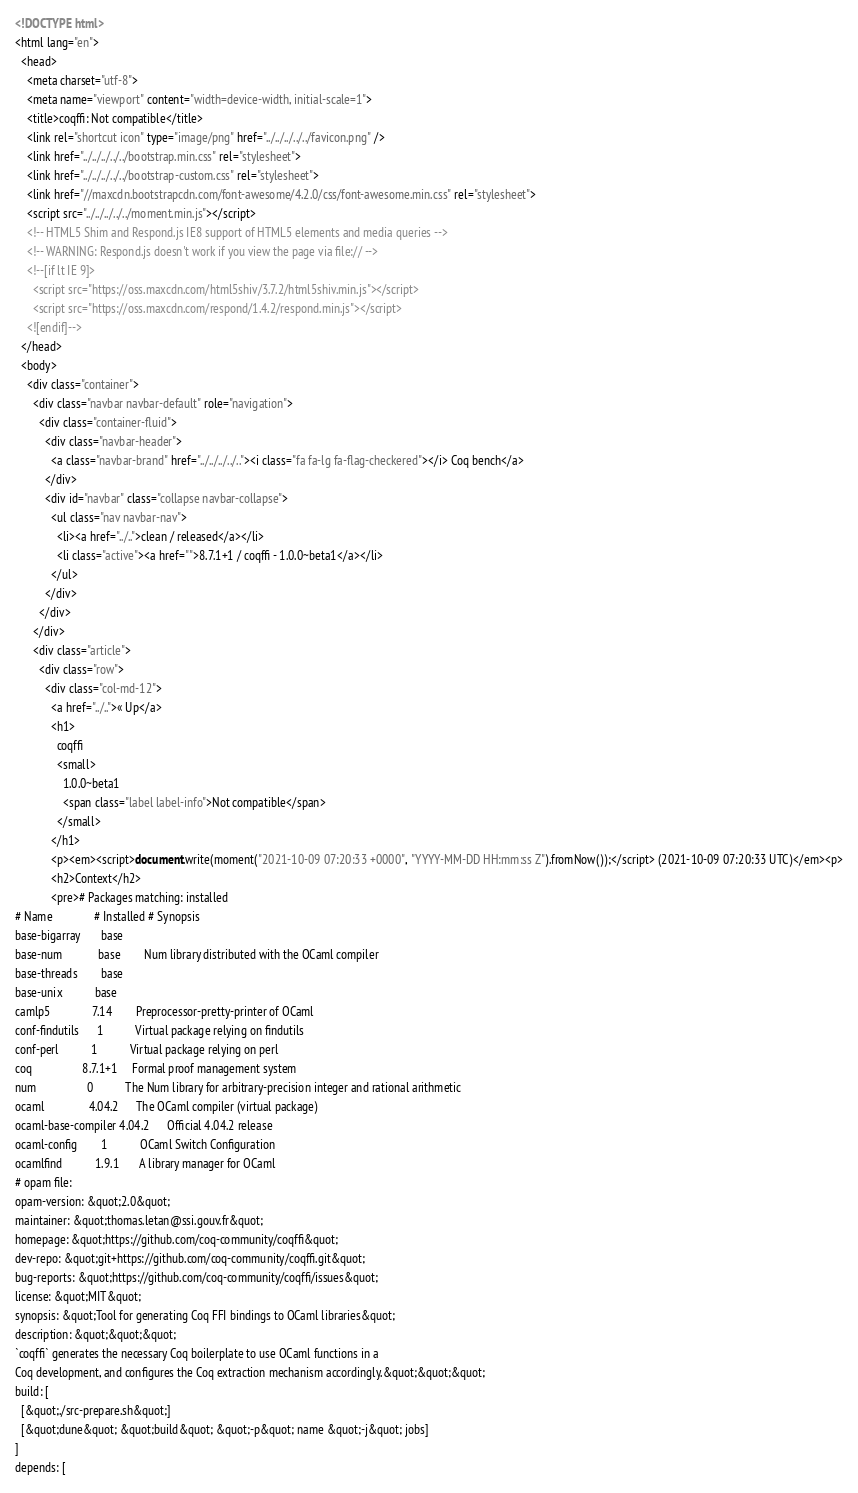<code> <loc_0><loc_0><loc_500><loc_500><_HTML_><!DOCTYPE html>
<html lang="en">
  <head>
    <meta charset="utf-8">
    <meta name="viewport" content="width=device-width, initial-scale=1">
    <title>coqffi: Not compatible</title>
    <link rel="shortcut icon" type="image/png" href="../../../../../favicon.png" />
    <link href="../../../../../bootstrap.min.css" rel="stylesheet">
    <link href="../../../../../bootstrap-custom.css" rel="stylesheet">
    <link href="//maxcdn.bootstrapcdn.com/font-awesome/4.2.0/css/font-awesome.min.css" rel="stylesheet">
    <script src="../../../../../moment.min.js"></script>
    <!-- HTML5 Shim and Respond.js IE8 support of HTML5 elements and media queries -->
    <!-- WARNING: Respond.js doesn't work if you view the page via file:// -->
    <!--[if lt IE 9]>
      <script src="https://oss.maxcdn.com/html5shiv/3.7.2/html5shiv.min.js"></script>
      <script src="https://oss.maxcdn.com/respond/1.4.2/respond.min.js"></script>
    <![endif]-->
  </head>
  <body>
    <div class="container">
      <div class="navbar navbar-default" role="navigation">
        <div class="container-fluid">
          <div class="navbar-header">
            <a class="navbar-brand" href="../../../../.."><i class="fa fa-lg fa-flag-checkered"></i> Coq bench</a>
          </div>
          <div id="navbar" class="collapse navbar-collapse">
            <ul class="nav navbar-nav">
              <li><a href="../..">clean / released</a></li>
              <li class="active"><a href="">8.7.1+1 / coqffi - 1.0.0~beta1</a></li>
            </ul>
          </div>
        </div>
      </div>
      <div class="article">
        <div class="row">
          <div class="col-md-12">
            <a href="../..">« Up</a>
            <h1>
              coqffi
              <small>
                1.0.0~beta1
                <span class="label label-info">Not compatible</span>
              </small>
            </h1>
            <p><em><script>document.write(moment("2021-10-09 07:20:33 +0000", "YYYY-MM-DD HH:mm:ss Z").fromNow());</script> (2021-10-09 07:20:33 UTC)</em><p>
            <h2>Context</h2>
            <pre># Packages matching: installed
# Name              # Installed # Synopsis
base-bigarray       base
base-num            base        Num library distributed with the OCaml compiler
base-threads        base
base-unix           base
camlp5              7.14        Preprocessor-pretty-printer of OCaml
conf-findutils      1           Virtual package relying on findutils
conf-perl           1           Virtual package relying on perl
coq                 8.7.1+1     Formal proof management system
num                 0           The Num library for arbitrary-precision integer and rational arithmetic
ocaml               4.04.2      The OCaml compiler (virtual package)
ocaml-base-compiler 4.04.2      Official 4.04.2 release
ocaml-config        1           OCaml Switch Configuration
ocamlfind           1.9.1       A library manager for OCaml
# opam file:
opam-version: &quot;2.0&quot;
maintainer: &quot;thomas.letan@ssi.gouv.fr&quot;
homepage: &quot;https://github.com/coq-community/coqffi&quot;
dev-repo: &quot;git+https://github.com/coq-community/coqffi.git&quot;
bug-reports: &quot;https://github.com/coq-community/coqffi/issues&quot;
license: &quot;MIT&quot;
synopsis: &quot;Tool for generating Coq FFI bindings to OCaml libraries&quot;
description: &quot;&quot;&quot;
`coqffi` generates the necessary Coq boilerplate to use OCaml functions in a
Coq development, and configures the Coq extraction mechanism accordingly.&quot;&quot;&quot;
build: [
  [&quot;./src-prepare.sh&quot;]
  [&quot;dune&quot; &quot;build&quot; &quot;-p&quot; name &quot;-j&quot; jobs]
]
depends: [</code> 